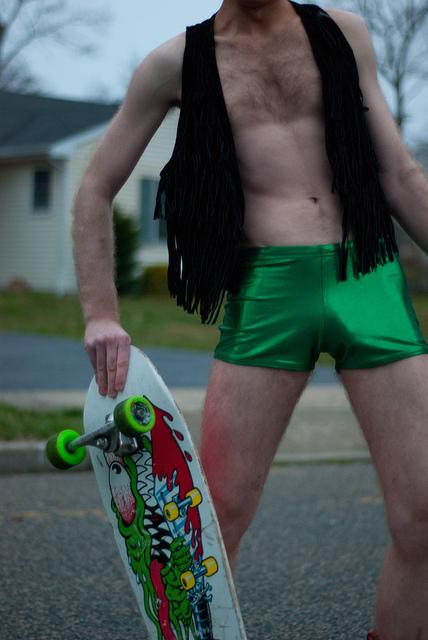Is the man wearing boxer shorts?
Quick response, please. No. What color are the wheels of the skateboard?
Answer briefly. Green. What is the man wearing?
Quick response, please. Shorts. Who is standing in the image?
Short answer required. Man. What is this person wearing?
Quick response, please. Shorts. What animal is painted on the skateboard?
Give a very brief answer. Alligator. What color is the skateboard?
Short answer required. White. Is this a woman?
Give a very brief answer. No. Why would the man put bananas in his suit?
Short answer required. Larger package. What is the man holding?
Short answer required. Skateboard. What color are the persons shorts?
Quick response, please. Green. Is this a beach or lake scenery?
Be succinct. No. How sane do you think this person is?
Quick response, please. Not very. Did the man just finish a trick?
Quick response, please. No. 